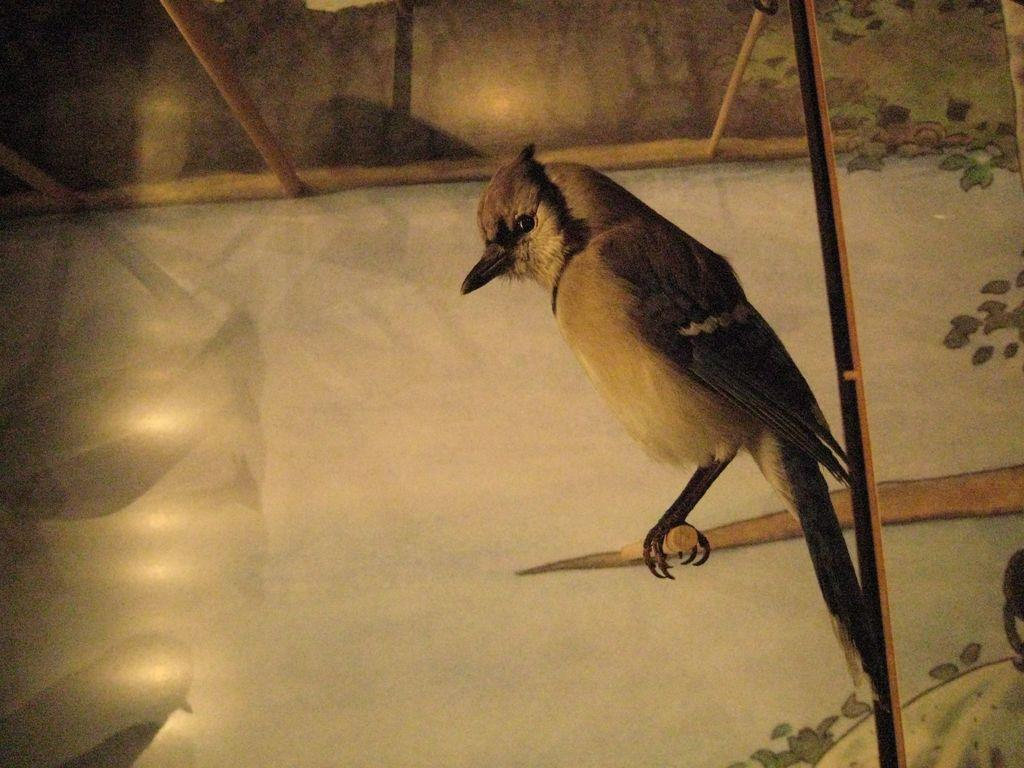What type of animal can be seen in the image? There is a bird in the image. How is the bird positioned in the image? The bird is on a stick. What can be seen in the background of the image? There is a wall in the background of the image. What is on the wall in the image? There is a painting on the wall. What objects are visible at the top of the image? There are sticks visible at the top of the image. What type of milk is being poured into the boy's glass in the image? There is no boy or glass of milk present in the image; it features a bird on a stick with a wall and painting in the background. 